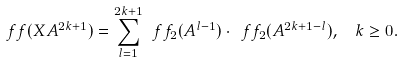Convert formula to latex. <formula><loc_0><loc_0><loc_500><loc_500>\ f f ( X A ^ { 2 k + 1 } ) = \sum _ { l = 1 } ^ { 2 k + 1 } \ f f _ { 2 } ( A ^ { l - 1 } ) \cdot \ f f _ { 2 } ( A ^ { 2 k + 1 - l } ) , \ \ k \geq 0 .</formula> 